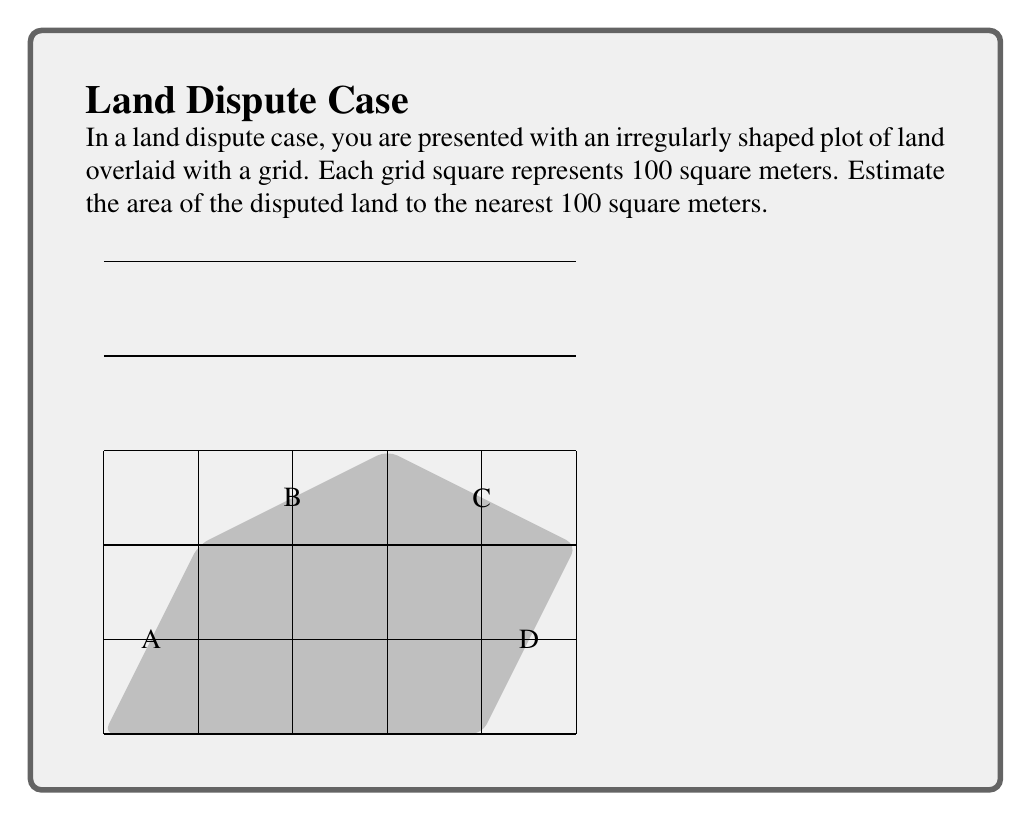Could you help me with this problem? To estimate the area of this irregularly shaped plot using the grid overlay method, we will:

1. Count the number of whole squares within the shape.
2. Estimate the fractional parts of squares along the edges.
3. Sum these values and multiply by the area of each grid square.

Step 1: Counting whole squares
There are 8 whole squares completely within the shape.

Step 2: Estimating fractional parts
- Along edge AB: approximately 1.5 squares
- Along edge BC: approximately 1 square
- Along edge CD: approximately 1 square
- Along edge DA: approximately 1.5 squares

Total of fractional parts: $1.5 + 1 + 1 + 1.5 = 5$ squares

Step 3: Summing and calculating the area
Total estimated squares: $8 + 5 = 13$ squares

Each square represents 100 square meters, so:

Estimated area $= 13 \times 100 = 1300$ square meters

Therefore, the estimated area of the disputed land is 1300 square meters.
Answer: 1300 $\text{m}^2$ 